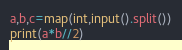<code> <loc_0><loc_0><loc_500><loc_500><_Python_>a,b,c=map(int,input().split())
print(a*b//2)</code> 